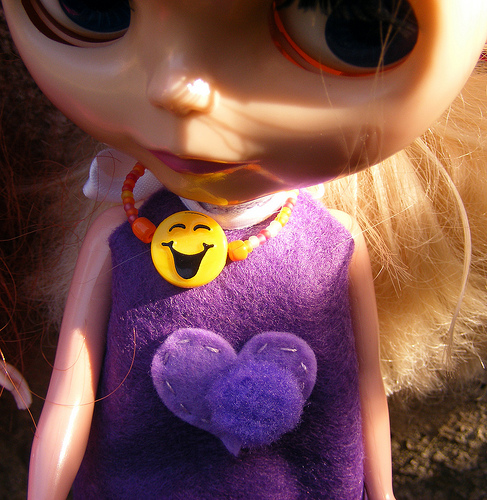<image>
Can you confirm if the smiley is under the angry face? Yes. The smiley is positioned underneath the angry face, with the angry face above it in the vertical space. 